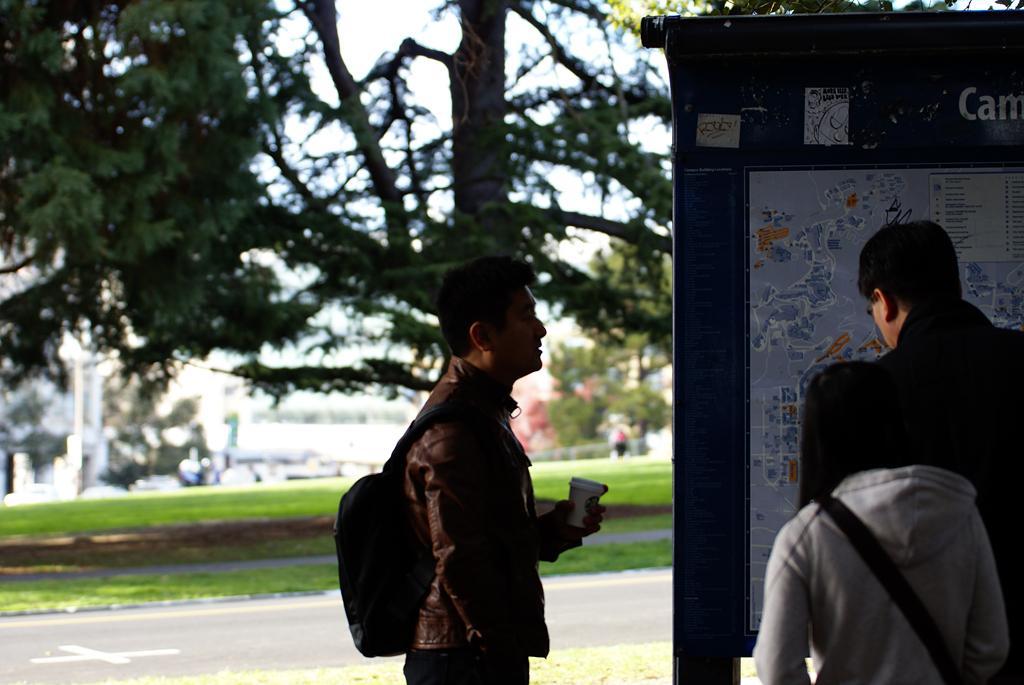Describe this image in one or two sentences. In this picture there are people and we can see board. In the background of the image it is blurry and we can see trees, grass and sky. 